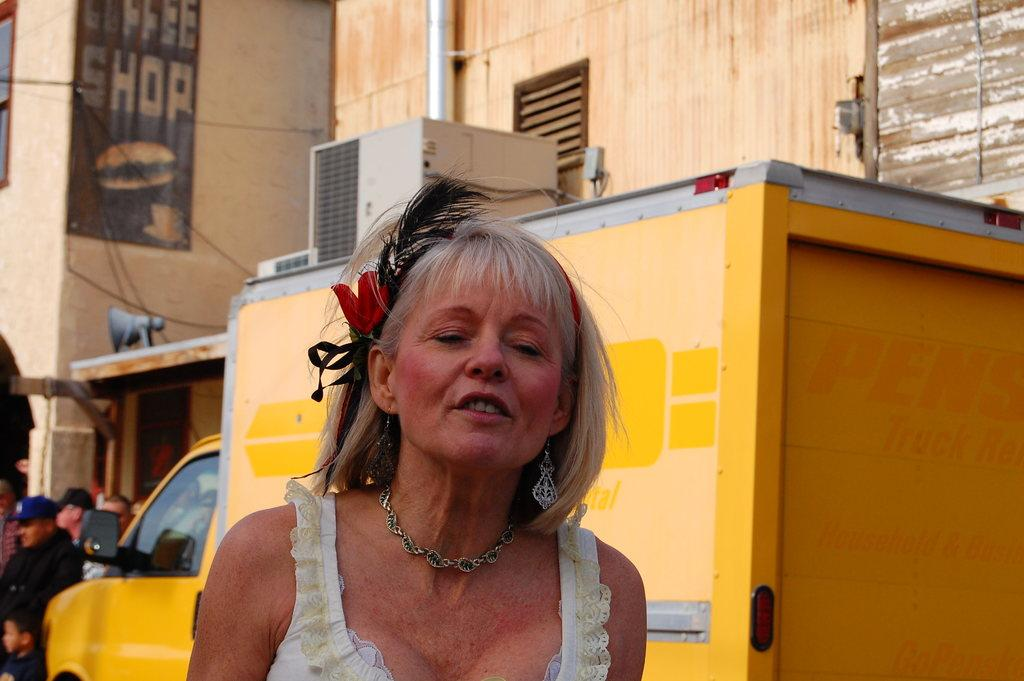<image>
Describe the image concisely. A woman with a strained expression stands in front of a building with a COFFEE SHOP sign painted on it. 